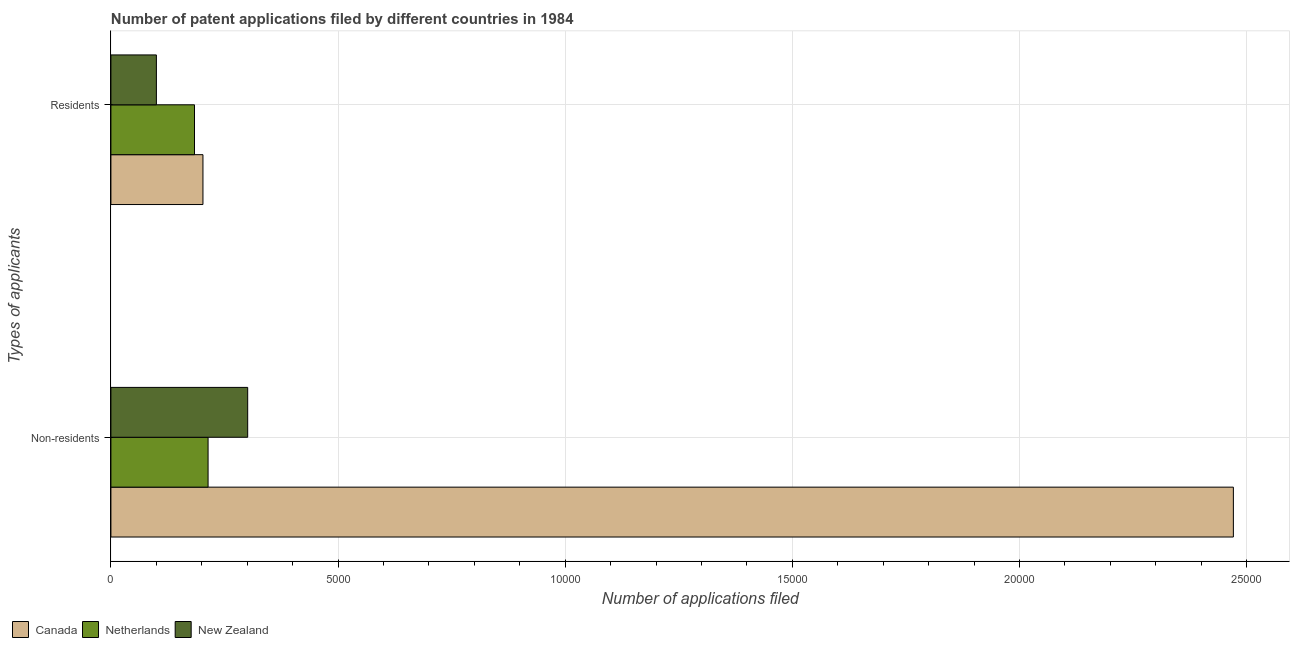Are the number of bars per tick equal to the number of legend labels?
Make the answer very short. Yes. How many bars are there on the 2nd tick from the top?
Make the answer very short. 3. How many bars are there on the 2nd tick from the bottom?
Keep it short and to the point. 3. What is the label of the 2nd group of bars from the top?
Provide a succinct answer. Non-residents. What is the number of patent applications by non residents in Netherlands?
Keep it short and to the point. 2139. Across all countries, what is the maximum number of patent applications by non residents?
Ensure brevity in your answer.  2.47e+04. Across all countries, what is the minimum number of patent applications by non residents?
Your response must be concise. 2139. In which country was the number of patent applications by residents maximum?
Make the answer very short. Canada. In which country was the number of patent applications by non residents minimum?
Provide a short and direct response. Netherlands. What is the total number of patent applications by residents in the graph?
Your answer should be very brief. 4867. What is the difference between the number of patent applications by residents in Netherlands and that in Canada?
Provide a short and direct response. -186. What is the difference between the number of patent applications by residents in Netherlands and the number of patent applications by non residents in New Zealand?
Provide a short and direct response. -1171. What is the average number of patent applications by residents per country?
Provide a short and direct response. 1622.33. What is the difference between the number of patent applications by residents and number of patent applications by non residents in Canada?
Give a very brief answer. -2.27e+04. What is the ratio of the number of patent applications by residents in Netherlands to that in New Zealand?
Your response must be concise. 1.84. In how many countries, is the number of patent applications by residents greater than the average number of patent applications by residents taken over all countries?
Offer a terse response. 2. What does the 1st bar from the top in Residents represents?
Keep it short and to the point. New Zealand. What does the 1st bar from the bottom in Non-residents represents?
Your answer should be very brief. Canada. How many bars are there?
Make the answer very short. 6. How many countries are there in the graph?
Your answer should be compact. 3. Does the graph contain any zero values?
Keep it short and to the point. No. What is the title of the graph?
Provide a succinct answer. Number of patent applications filed by different countries in 1984. Does "Albania" appear as one of the legend labels in the graph?
Make the answer very short. No. What is the label or title of the X-axis?
Offer a terse response. Number of applications filed. What is the label or title of the Y-axis?
Give a very brief answer. Types of applicants. What is the Number of applications filed in Canada in Non-residents?
Offer a very short reply. 2.47e+04. What is the Number of applications filed in Netherlands in Non-residents?
Offer a terse response. 2139. What is the Number of applications filed in New Zealand in Non-residents?
Your response must be concise. 3011. What is the Number of applications filed in Canada in Residents?
Your response must be concise. 2026. What is the Number of applications filed in Netherlands in Residents?
Give a very brief answer. 1840. What is the Number of applications filed in New Zealand in Residents?
Your response must be concise. 1001. Across all Types of applicants, what is the maximum Number of applications filed in Canada?
Your answer should be very brief. 2.47e+04. Across all Types of applicants, what is the maximum Number of applications filed in Netherlands?
Provide a succinct answer. 2139. Across all Types of applicants, what is the maximum Number of applications filed of New Zealand?
Give a very brief answer. 3011. Across all Types of applicants, what is the minimum Number of applications filed in Canada?
Your answer should be very brief. 2026. Across all Types of applicants, what is the minimum Number of applications filed of Netherlands?
Keep it short and to the point. 1840. Across all Types of applicants, what is the minimum Number of applications filed in New Zealand?
Your answer should be compact. 1001. What is the total Number of applications filed of Canada in the graph?
Offer a terse response. 2.67e+04. What is the total Number of applications filed of Netherlands in the graph?
Offer a very short reply. 3979. What is the total Number of applications filed of New Zealand in the graph?
Your response must be concise. 4012. What is the difference between the Number of applications filed of Canada in Non-residents and that in Residents?
Your response must be concise. 2.27e+04. What is the difference between the Number of applications filed in Netherlands in Non-residents and that in Residents?
Ensure brevity in your answer.  299. What is the difference between the Number of applications filed in New Zealand in Non-residents and that in Residents?
Give a very brief answer. 2010. What is the difference between the Number of applications filed in Canada in Non-residents and the Number of applications filed in Netherlands in Residents?
Your response must be concise. 2.29e+04. What is the difference between the Number of applications filed in Canada in Non-residents and the Number of applications filed in New Zealand in Residents?
Make the answer very short. 2.37e+04. What is the difference between the Number of applications filed of Netherlands in Non-residents and the Number of applications filed of New Zealand in Residents?
Keep it short and to the point. 1138. What is the average Number of applications filed of Canada per Types of applicants?
Make the answer very short. 1.34e+04. What is the average Number of applications filed in Netherlands per Types of applicants?
Offer a terse response. 1989.5. What is the average Number of applications filed in New Zealand per Types of applicants?
Offer a very short reply. 2006. What is the difference between the Number of applications filed of Canada and Number of applications filed of Netherlands in Non-residents?
Offer a terse response. 2.26e+04. What is the difference between the Number of applications filed of Canada and Number of applications filed of New Zealand in Non-residents?
Offer a very short reply. 2.17e+04. What is the difference between the Number of applications filed in Netherlands and Number of applications filed in New Zealand in Non-residents?
Provide a succinct answer. -872. What is the difference between the Number of applications filed of Canada and Number of applications filed of Netherlands in Residents?
Your answer should be very brief. 186. What is the difference between the Number of applications filed of Canada and Number of applications filed of New Zealand in Residents?
Provide a short and direct response. 1025. What is the difference between the Number of applications filed in Netherlands and Number of applications filed in New Zealand in Residents?
Make the answer very short. 839. What is the ratio of the Number of applications filed in Canada in Non-residents to that in Residents?
Offer a very short reply. 12.2. What is the ratio of the Number of applications filed in Netherlands in Non-residents to that in Residents?
Provide a short and direct response. 1.16. What is the ratio of the Number of applications filed in New Zealand in Non-residents to that in Residents?
Offer a very short reply. 3.01. What is the difference between the highest and the second highest Number of applications filed of Canada?
Offer a terse response. 2.27e+04. What is the difference between the highest and the second highest Number of applications filed of Netherlands?
Make the answer very short. 299. What is the difference between the highest and the second highest Number of applications filed of New Zealand?
Provide a succinct answer. 2010. What is the difference between the highest and the lowest Number of applications filed in Canada?
Your response must be concise. 2.27e+04. What is the difference between the highest and the lowest Number of applications filed of Netherlands?
Make the answer very short. 299. What is the difference between the highest and the lowest Number of applications filed in New Zealand?
Your answer should be compact. 2010. 